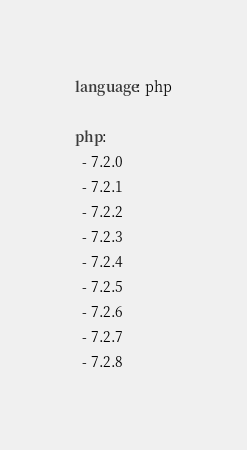Convert code to text. <code><loc_0><loc_0><loc_500><loc_500><_YAML_>language: php

php:
  - 7.2.0
  - 7.2.1
  - 7.2.2
  - 7.2.3
  - 7.2.4
  - 7.2.5
  - 7.2.6
  - 7.2.7
  - 7.2.8</code> 